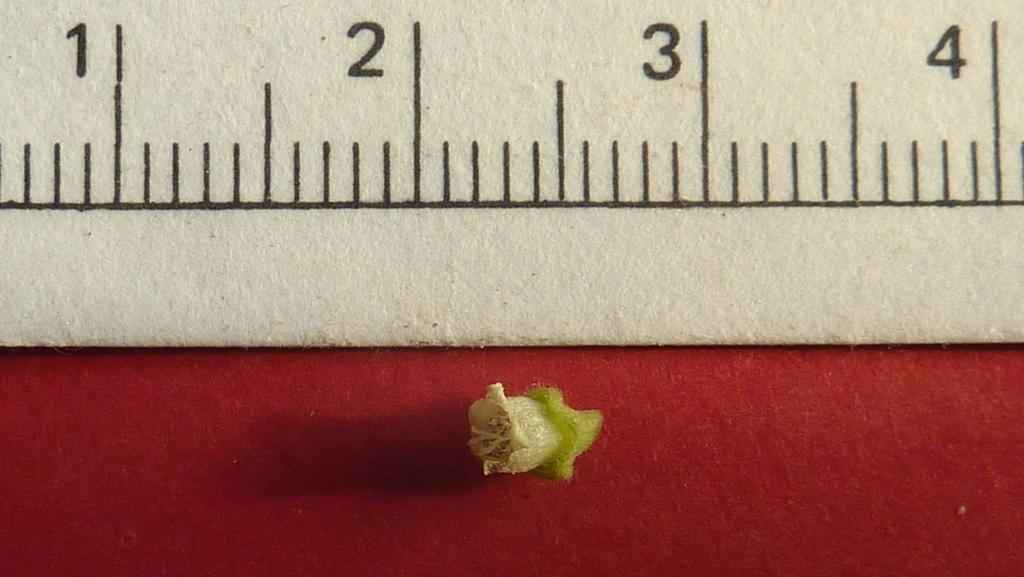Provide a one-sentence caption for the provided image. A very small seed sits under a ruler with the 1, 2, 3, 4 inche marks noted at the top. 